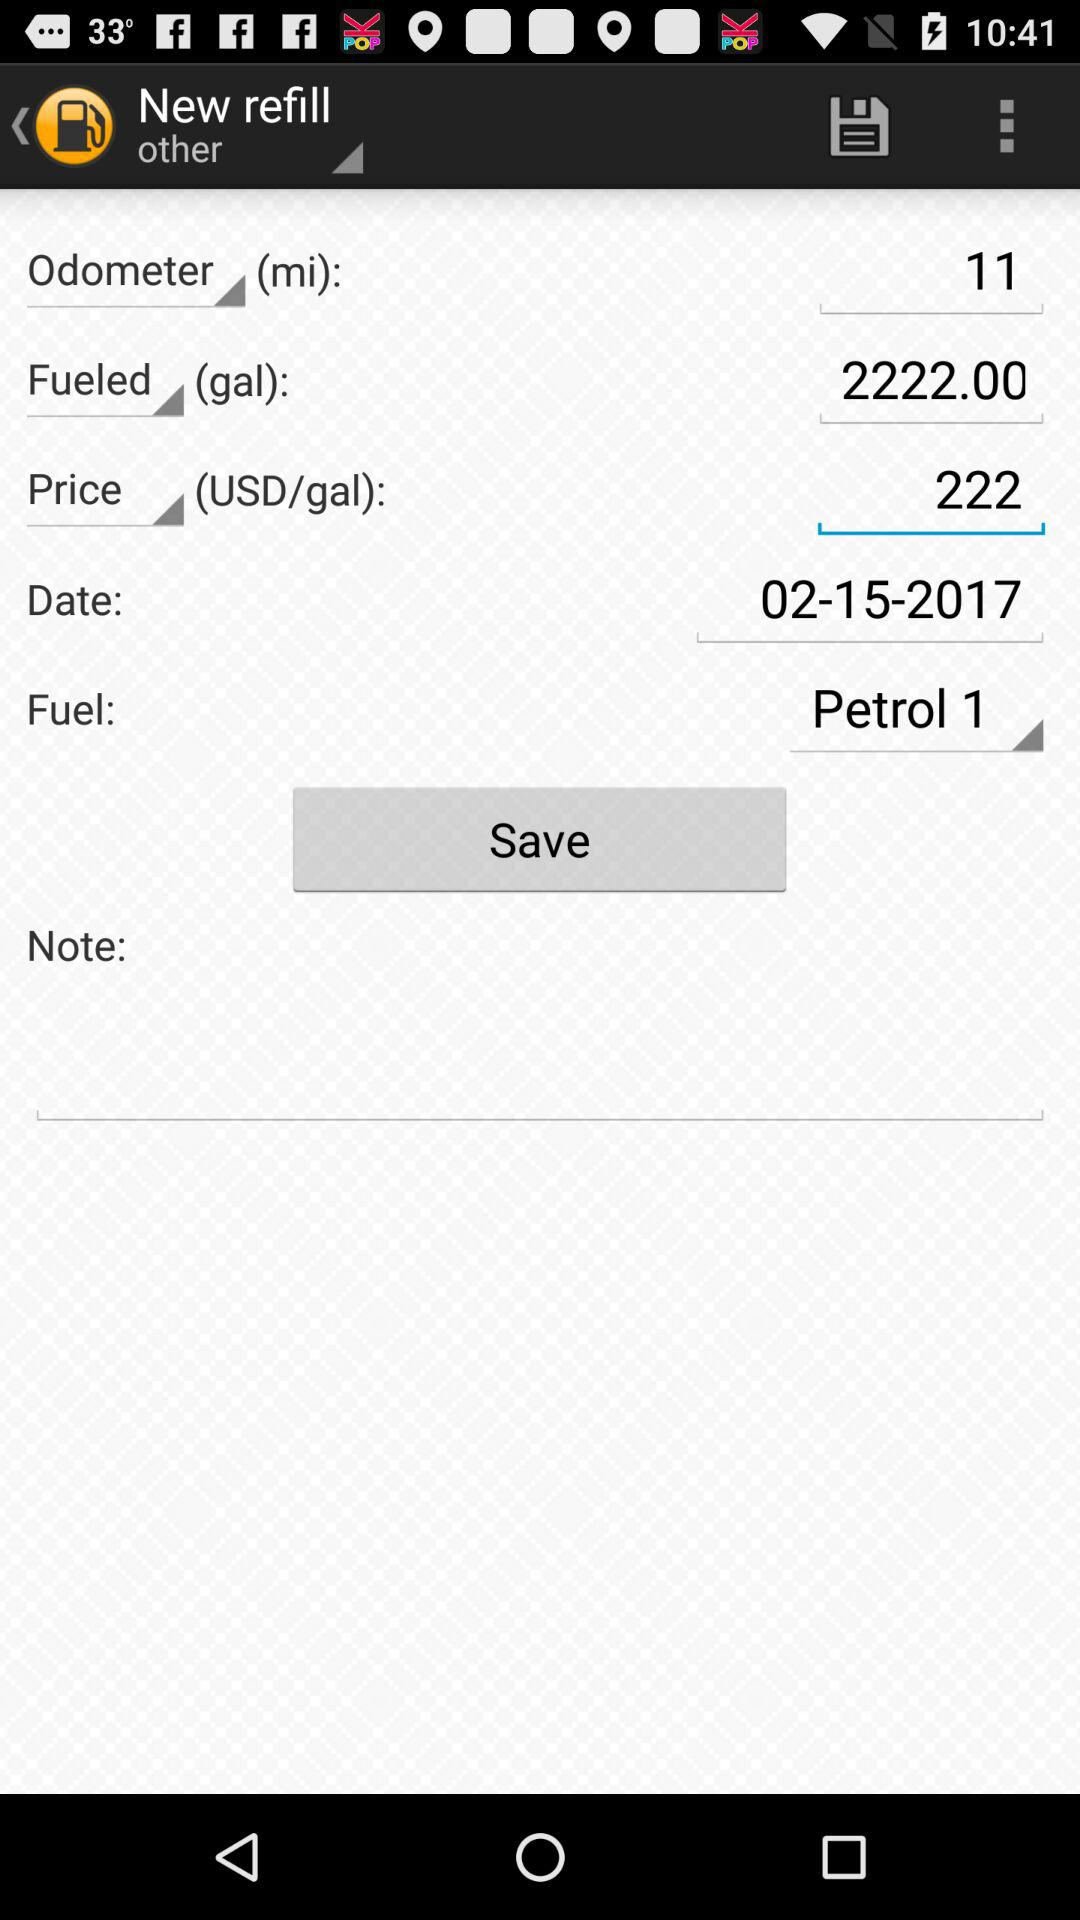How many gallons of fuel were filled? The Fuel filled was 2222 gallons. 